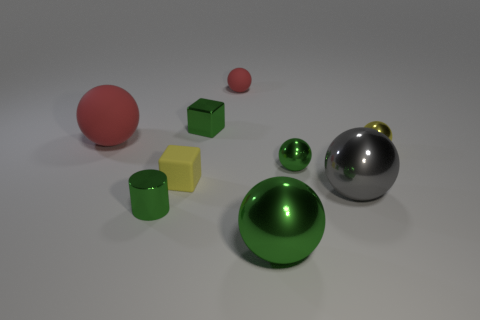Subtract all small rubber balls. How many balls are left? 5 Add 1 green shiny things. How many objects exist? 10 Subtract all yellow blocks. How many red spheres are left? 2 Subtract 2 spheres. How many spheres are left? 4 Subtract all green spheres. How many spheres are left? 4 Subtract all purple balls. Subtract all purple cubes. How many balls are left? 6 Subtract all tiny yellow matte blocks. Subtract all large cyan metallic blocks. How many objects are left? 8 Add 7 red matte balls. How many red matte balls are left? 9 Add 3 blocks. How many blocks exist? 5 Subtract 0 red cylinders. How many objects are left? 9 